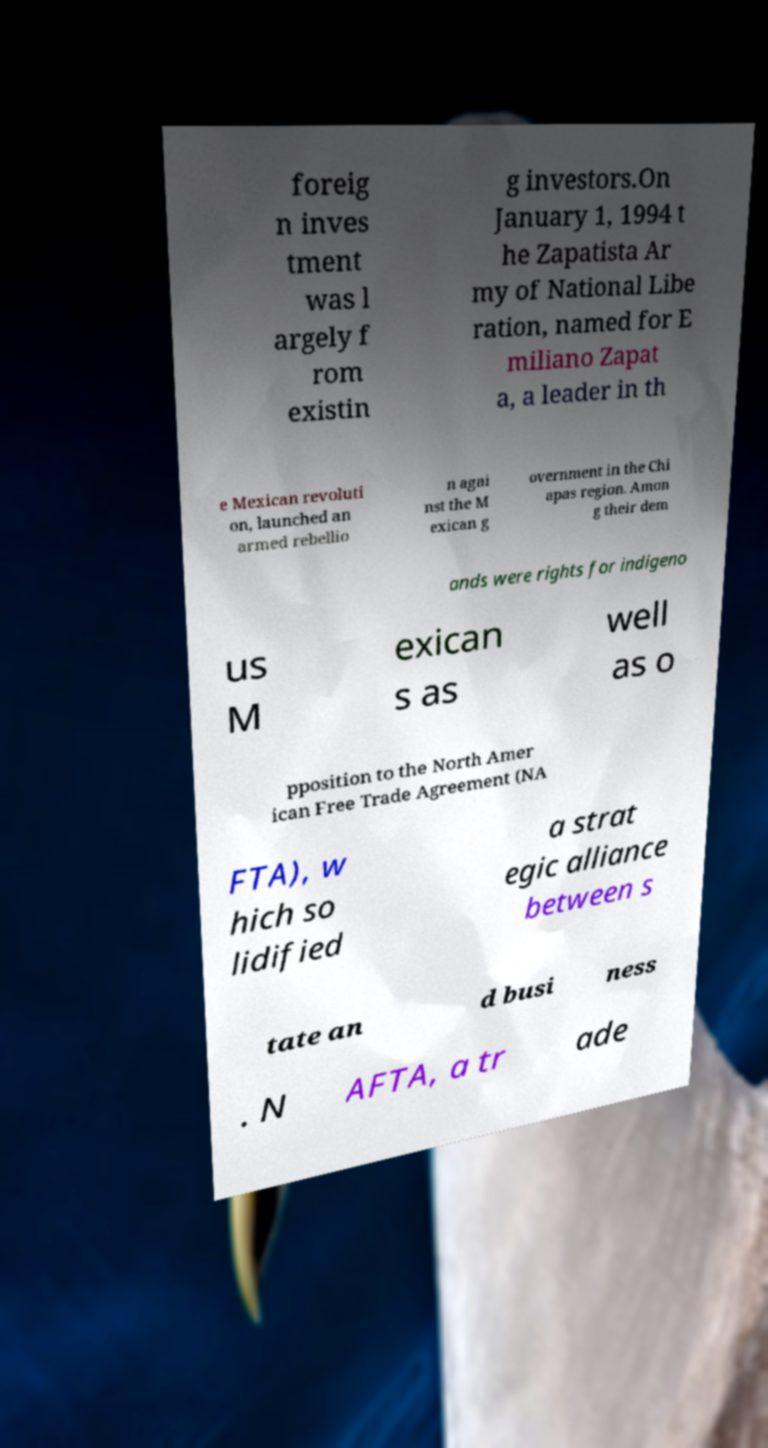Please identify and transcribe the text found in this image. foreig n inves tment was l argely f rom existin g investors.On January 1, 1994 t he Zapatista Ar my of National Libe ration, named for E miliano Zapat a, a leader in th e Mexican revoluti on, launched an armed rebellio n agai nst the M exican g overnment in the Chi apas region. Amon g their dem ands were rights for indigeno us M exican s as well as o pposition to the North Amer ican Free Trade Agreement (NA FTA), w hich so lidified a strat egic alliance between s tate an d busi ness . N AFTA, a tr ade 